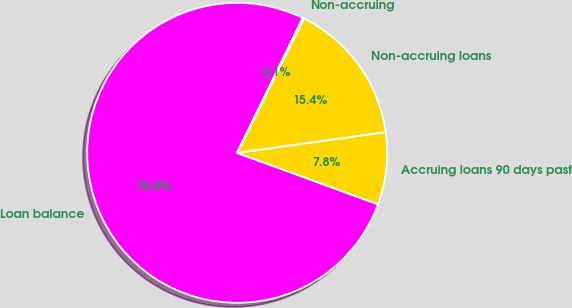Convert chart. <chart><loc_0><loc_0><loc_500><loc_500><pie_chart><fcel>Loan balance<fcel>Accruing loans 90 days past<fcel>Non-accruing loans<fcel>Non-accruing<nl><fcel>76.62%<fcel>7.79%<fcel>15.44%<fcel>0.14%<nl></chart> 